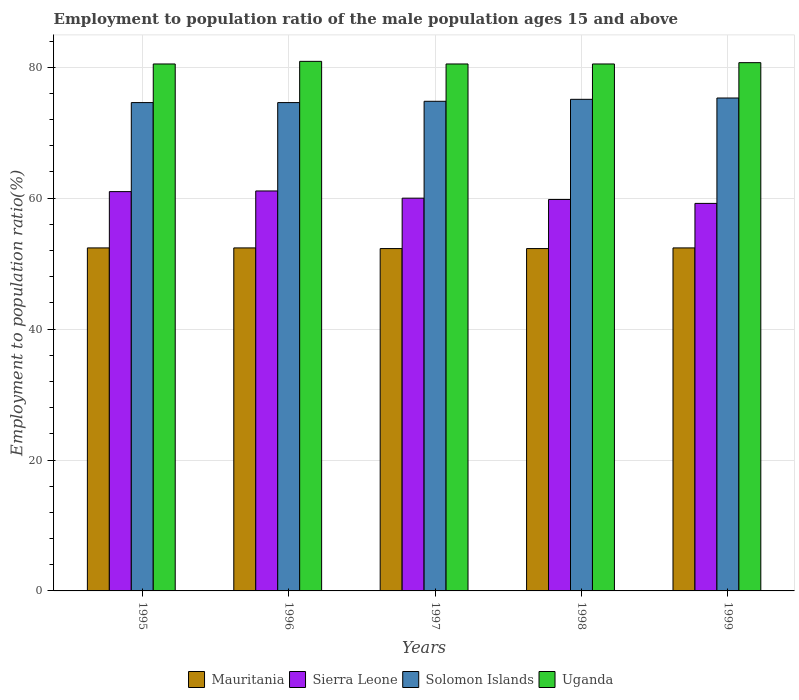How many different coloured bars are there?
Make the answer very short. 4. Are the number of bars per tick equal to the number of legend labels?
Ensure brevity in your answer.  Yes. Are the number of bars on each tick of the X-axis equal?
Offer a very short reply. Yes. How many bars are there on the 2nd tick from the left?
Offer a very short reply. 4. How many bars are there on the 2nd tick from the right?
Your response must be concise. 4. What is the employment to population ratio in Uganda in 1995?
Ensure brevity in your answer.  80.5. Across all years, what is the maximum employment to population ratio in Sierra Leone?
Give a very brief answer. 61.1. Across all years, what is the minimum employment to population ratio in Mauritania?
Your answer should be compact. 52.3. What is the total employment to population ratio in Sierra Leone in the graph?
Offer a very short reply. 301.1. What is the difference between the employment to population ratio in Uganda in 1996 and that in 1997?
Ensure brevity in your answer.  0.4. What is the difference between the employment to population ratio in Mauritania in 1997 and the employment to population ratio in Sierra Leone in 1996?
Offer a very short reply. -8.8. What is the average employment to population ratio in Uganda per year?
Offer a terse response. 80.62. In the year 1995, what is the difference between the employment to population ratio in Sierra Leone and employment to population ratio in Uganda?
Offer a very short reply. -19.5. What is the ratio of the employment to population ratio in Uganda in 1996 to that in 1997?
Make the answer very short. 1. Is the employment to population ratio in Sierra Leone in 1995 less than that in 1997?
Ensure brevity in your answer.  No. Is the difference between the employment to population ratio in Sierra Leone in 1996 and 1998 greater than the difference between the employment to population ratio in Uganda in 1996 and 1998?
Offer a terse response. Yes. What is the difference between the highest and the second highest employment to population ratio in Uganda?
Give a very brief answer. 0.2. What is the difference between the highest and the lowest employment to population ratio in Sierra Leone?
Provide a succinct answer. 1.9. Is it the case that in every year, the sum of the employment to population ratio in Uganda and employment to population ratio in Sierra Leone is greater than the sum of employment to population ratio in Mauritania and employment to population ratio in Solomon Islands?
Provide a short and direct response. No. What does the 4th bar from the left in 1998 represents?
Your answer should be compact. Uganda. What does the 1st bar from the right in 1999 represents?
Provide a short and direct response. Uganda. Is it the case that in every year, the sum of the employment to population ratio in Mauritania and employment to population ratio in Sierra Leone is greater than the employment to population ratio in Uganda?
Offer a terse response. Yes. How many bars are there?
Offer a very short reply. 20. Are all the bars in the graph horizontal?
Your response must be concise. No. What is the difference between two consecutive major ticks on the Y-axis?
Make the answer very short. 20. Are the values on the major ticks of Y-axis written in scientific E-notation?
Your answer should be very brief. No. Does the graph contain any zero values?
Your answer should be very brief. No. Where does the legend appear in the graph?
Offer a very short reply. Bottom center. What is the title of the graph?
Keep it short and to the point. Employment to population ratio of the male population ages 15 and above. What is the Employment to population ratio(%) in Mauritania in 1995?
Provide a succinct answer. 52.4. What is the Employment to population ratio(%) of Solomon Islands in 1995?
Your answer should be very brief. 74.6. What is the Employment to population ratio(%) in Uganda in 1995?
Ensure brevity in your answer.  80.5. What is the Employment to population ratio(%) in Mauritania in 1996?
Provide a succinct answer. 52.4. What is the Employment to population ratio(%) of Sierra Leone in 1996?
Provide a short and direct response. 61.1. What is the Employment to population ratio(%) of Solomon Islands in 1996?
Offer a very short reply. 74.6. What is the Employment to population ratio(%) in Uganda in 1996?
Keep it short and to the point. 80.9. What is the Employment to population ratio(%) of Mauritania in 1997?
Offer a very short reply. 52.3. What is the Employment to population ratio(%) of Solomon Islands in 1997?
Provide a short and direct response. 74.8. What is the Employment to population ratio(%) of Uganda in 1997?
Give a very brief answer. 80.5. What is the Employment to population ratio(%) of Mauritania in 1998?
Offer a very short reply. 52.3. What is the Employment to population ratio(%) in Sierra Leone in 1998?
Your response must be concise. 59.8. What is the Employment to population ratio(%) in Solomon Islands in 1998?
Your answer should be compact. 75.1. What is the Employment to population ratio(%) of Uganda in 1998?
Offer a terse response. 80.5. What is the Employment to population ratio(%) of Mauritania in 1999?
Give a very brief answer. 52.4. What is the Employment to population ratio(%) of Sierra Leone in 1999?
Your answer should be compact. 59.2. What is the Employment to population ratio(%) of Solomon Islands in 1999?
Make the answer very short. 75.3. What is the Employment to population ratio(%) in Uganda in 1999?
Give a very brief answer. 80.7. Across all years, what is the maximum Employment to population ratio(%) in Mauritania?
Provide a succinct answer. 52.4. Across all years, what is the maximum Employment to population ratio(%) in Sierra Leone?
Your response must be concise. 61.1. Across all years, what is the maximum Employment to population ratio(%) of Solomon Islands?
Provide a short and direct response. 75.3. Across all years, what is the maximum Employment to population ratio(%) in Uganda?
Provide a succinct answer. 80.9. Across all years, what is the minimum Employment to population ratio(%) in Mauritania?
Your answer should be compact. 52.3. Across all years, what is the minimum Employment to population ratio(%) of Sierra Leone?
Your answer should be compact. 59.2. Across all years, what is the minimum Employment to population ratio(%) in Solomon Islands?
Make the answer very short. 74.6. Across all years, what is the minimum Employment to population ratio(%) in Uganda?
Offer a terse response. 80.5. What is the total Employment to population ratio(%) of Mauritania in the graph?
Ensure brevity in your answer.  261.8. What is the total Employment to population ratio(%) of Sierra Leone in the graph?
Offer a terse response. 301.1. What is the total Employment to population ratio(%) in Solomon Islands in the graph?
Ensure brevity in your answer.  374.4. What is the total Employment to population ratio(%) in Uganda in the graph?
Your answer should be compact. 403.1. What is the difference between the Employment to population ratio(%) of Mauritania in 1995 and that in 1996?
Provide a short and direct response. 0. What is the difference between the Employment to population ratio(%) in Uganda in 1995 and that in 1996?
Offer a very short reply. -0.4. What is the difference between the Employment to population ratio(%) of Mauritania in 1995 and that in 1997?
Provide a succinct answer. 0.1. What is the difference between the Employment to population ratio(%) of Solomon Islands in 1995 and that in 1997?
Offer a very short reply. -0.2. What is the difference between the Employment to population ratio(%) in Solomon Islands in 1995 and that in 1998?
Provide a succinct answer. -0.5. What is the difference between the Employment to population ratio(%) of Uganda in 1995 and that in 1998?
Give a very brief answer. 0. What is the difference between the Employment to population ratio(%) in Sierra Leone in 1995 and that in 1999?
Provide a short and direct response. 1.8. What is the difference between the Employment to population ratio(%) of Solomon Islands in 1995 and that in 1999?
Give a very brief answer. -0.7. What is the difference between the Employment to population ratio(%) in Uganda in 1995 and that in 1999?
Make the answer very short. -0.2. What is the difference between the Employment to population ratio(%) in Uganda in 1996 and that in 1997?
Your response must be concise. 0.4. What is the difference between the Employment to population ratio(%) of Sierra Leone in 1996 and that in 1998?
Provide a short and direct response. 1.3. What is the difference between the Employment to population ratio(%) in Mauritania in 1997 and that in 1998?
Your response must be concise. 0. What is the difference between the Employment to population ratio(%) of Solomon Islands in 1997 and that in 1999?
Give a very brief answer. -0.5. What is the difference between the Employment to population ratio(%) in Mauritania in 1998 and that in 1999?
Your response must be concise. -0.1. What is the difference between the Employment to population ratio(%) in Solomon Islands in 1998 and that in 1999?
Give a very brief answer. -0.2. What is the difference between the Employment to population ratio(%) in Mauritania in 1995 and the Employment to population ratio(%) in Solomon Islands in 1996?
Offer a very short reply. -22.2. What is the difference between the Employment to population ratio(%) in Mauritania in 1995 and the Employment to population ratio(%) in Uganda in 1996?
Your answer should be compact. -28.5. What is the difference between the Employment to population ratio(%) in Sierra Leone in 1995 and the Employment to population ratio(%) in Solomon Islands in 1996?
Give a very brief answer. -13.6. What is the difference between the Employment to population ratio(%) of Sierra Leone in 1995 and the Employment to population ratio(%) of Uganda in 1996?
Provide a short and direct response. -19.9. What is the difference between the Employment to population ratio(%) of Solomon Islands in 1995 and the Employment to population ratio(%) of Uganda in 1996?
Offer a very short reply. -6.3. What is the difference between the Employment to population ratio(%) of Mauritania in 1995 and the Employment to population ratio(%) of Sierra Leone in 1997?
Ensure brevity in your answer.  -7.6. What is the difference between the Employment to population ratio(%) in Mauritania in 1995 and the Employment to population ratio(%) in Solomon Islands in 1997?
Make the answer very short. -22.4. What is the difference between the Employment to population ratio(%) of Mauritania in 1995 and the Employment to population ratio(%) of Uganda in 1997?
Provide a succinct answer. -28.1. What is the difference between the Employment to population ratio(%) in Sierra Leone in 1995 and the Employment to population ratio(%) in Solomon Islands in 1997?
Offer a terse response. -13.8. What is the difference between the Employment to population ratio(%) in Sierra Leone in 1995 and the Employment to population ratio(%) in Uganda in 1997?
Your answer should be very brief. -19.5. What is the difference between the Employment to population ratio(%) in Solomon Islands in 1995 and the Employment to population ratio(%) in Uganda in 1997?
Offer a very short reply. -5.9. What is the difference between the Employment to population ratio(%) in Mauritania in 1995 and the Employment to population ratio(%) in Sierra Leone in 1998?
Offer a very short reply. -7.4. What is the difference between the Employment to population ratio(%) of Mauritania in 1995 and the Employment to population ratio(%) of Solomon Islands in 1998?
Your answer should be compact. -22.7. What is the difference between the Employment to population ratio(%) in Mauritania in 1995 and the Employment to population ratio(%) in Uganda in 1998?
Offer a terse response. -28.1. What is the difference between the Employment to population ratio(%) of Sierra Leone in 1995 and the Employment to population ratio(%) of Solomon Islands in 1998?
Keep it short and to the point. -14.1. What is the difference between the Employment to population ratio(%) in Sierra Leone in 1995 and the Employment to population ratio(%) in Uganda in 1998?
Provide a short and direct response. -19.5. What is the difference between the Employment to population ratio(%) in Solomon Islands in 1995 and the Employment to population ratio(%) in Uganda in 1998?
Provide a short and direct response. -5.9. What is the difference between the Employment to population ratio(%) of Mauritania in 1995 and the Employment to population ratio(%) of Sierra Leone in 1999?
Offer a terse response. -6.8. What is the difference between the Employment to population ratio(%) in Mauritania in 1995 and the Employment to population ratio(%) in Solomon Islands in 1999?
Offer a very short reply. -22.9. What is the difference between the Employment to population ratio(%) in Mauritania in 1995 and the Employment to population ratio(%) in Uganda in 1999?
Offer a very short reply. -28.3. What is the difference between the Employment to population ratio(%) of Sierra Leone in 1995 and the Employment to population ratio(%) of Solomon Islands in 1999?
Keep it short and to the point. -14.3. What is the difference between the Employment to population ratio(%) in Sierra Leone in 1995 and the Employment to population ratio(%) in Uganda in 1999?
Provide a succinct answer. -19.7. What is the difference between the Employment to population ratio(%) of Mauritania in 1996 and the Employment to population ratio(%) of Solomon Islands in 1997?
Provide a short and direct response. -22.4. What is the difference between the Employment to population ratio(%) of Mauritania in 1996 and the Employment to population ratio(%) of Uganda in 1997?
Provide a succinct answer. -28.1. What is the difference between the Employment to population ratio(%) in Sierra Leone in 1996 and the Employment to population ratio(%) in Solomon Islands in 1997?
Give a very brief answer. -13.7. What is the difference between the Employment to population ratio(%) of Sierra Leone in 1996 and the Employment to population ratio(%) of Uganda in 1997?
Ensure brevity in your answer.  -19.4. What is the difference between the Employment to population ratio(%) of Mauritania in 1996 and the Employment to population ratio(%) of Solomon Islands in 1998?
Make the answer very short. -22.7. What is the difference between the Employment to population ratio(%) in Mauritania in 1996 and the Employment to population ratio(%) in Uganda in 1998?
Provide a short and direct response. -28.1. What is the difference between the Employment to population ratio(%) in Sierra Leone in 1996 and the Employment to population ratio(%) in Uganda in 1998?
Your answer should be compact. -19.4. What is the difference between the Employment to population ratio(%) in Solomon Islands in 1996 and the Employment to population ratio(%) in Uganda in 1998?
Give a very brief answer. -5.9. What is the difference between the Employment to population ratio(%) in Mauritania in 1996 and the Employment to population ratio(%) in Solomon Islands in 1999?
Your answer should be compact. -22.9. What is the difference between the Employment to population ratio(%) in Mauritania in 1996 and the Employment to population ratio(%) in Uganda in 1999?
Your response must be concise. -28.3. What is the difference between the Employment to population ratio(%) in Sierra Leone in 1996 and the Employment to population ratio(%) in Solomon Islands in 1999?
Provide a succinct answer. -14.2. What is the difference between the Employment to population ratio(%) of Sierra Leone in 1996 and the Employment to population ratio(%) of Uganda in 1999?
Give a very brief answer. -19.6. What is the difference between the Employment to population ratio(%) in Solomon Islands in 1996 and the Employment to population ratio(%) in Uganda in 1999?
Offer a very short reply. -6.1. What is the difference between the Employment to population ratio(%) of Mauritania in 1997 and the Employment to population ratio(%) of Sierra Leone in 1998?
Your answer should be very brief. -7.5. What is the difference between the Employment to population ratio(%) of Mauritania in 1997 and the Employment to population ratio(%) of Solomon Islands in 1998?
Make the answer very short. -22.8. What is the difference between the Employment to population ratio(%) of Mauritania in 1997 and the Employment to population ratio(%) of Uganda in 1998?
Keep it short and to the point. -28.2. What is the difference between the Employment to population ratio(%) in Sierra Leone in 1997 and the Employment to population ratio(%) in Solomon Islands in 1998?
Ensure brevity in your answer.  -15.1. What is the difference between the Employment to population ratio(%) of Sierra Leone in 1997 and the Employment to population ratio(%) of Uganda in 1998?
Offer a very short reply. -20.5. What is the difference between the Employment to population ratio(%) of Solomon Islands in 1997 and the Employment to population ratio(%) of Uganda in 1998?
Your response must be concise. -5.7. What is the difference between the Employment to population ratio(%) of Mauritania in 1997 and the Employment to population ratio(%) of Sierra Leone in 1999?
Make the answer very short. -6.9. What is the difference between the Employment to population ratio(%) in Mauritania in 1997 and the Employment to population ratio(%) in Solomon Islands in 1999?
Ensure brevity in your answer.  -23. What is the difference between the Employment to population ratio(%) of Mauritania in 1997 and the Employment to population ratio(%) of Uganda in 1999?
Ensure brevity in your answer.  -28.4. What is the difference between the Employment to population ratio(%) of Sierra Leone in 1997 and the Employment to population ratio(%) of Solomon Islands in 1999?
Keep it short and to the point. -15.3. What is the difference between the Employment to population ratio(%) in Sierra Leone in 1997 and the Employment to population ratio(%) in Uganda in 1999?
Offer a terse response. -20.7. What is the difference between the Employment to population ratio(%) in Mauritania in 1998 and the Employment to population ratio(%) in Solomon Islands in 1999?
Give a very brief answer. -23. What is the difference between the Employment to population ratio(%) in Mauritania in 1998 and the Employment to population ratio(%) in Uganda in 1999?
Your response must be concise. -28.4. What is the difference between the Employment to population ratio(%) in Sierra Leone in 1998 and the Employment to population ratio(%) in Solomon Islands in 1999?
Your answer should be very brief. -15.5. What is the difference between the Employment to population ratio(%) in Sierra Leone in 1998 and the Employment to population ratio(%) in Uganda in 1999?
Make the answer very short. -20.9. What is the average Employment to population ratio(%) in Mauritania per year?
Your answer should be very brief. 52.36. What is the average Employment to population ratio(%) of Sierra Leone per year?
Provide a short and direct response. 60.22. What is the average Employment to population ratio(%) of Solomon Islands per year?
Offer a very short reply. 74.88. What is the average Employment to population ratio(%) of Uganda per year?
Your answer should be compact. 80.62. In the year 1995, what is the difference between the Employment to population ratio(%) in Mauritania and Employment to population ratio(%) in Sierra Leone?
Your answer should be very brief. -8.6. In the year 1995, what is the difference between the Employment to population ratio(%) of Mauritania and Employment to population ratio(%) of Solomon Islands?
Keep it short and to the point. -22.2. In the year 1995, what is the difference between the Employment to population ratio(%) in Mauritania and Employment to population ratio(%) in Uganda?
Your response must be concise. -28.1. In the year 1995, what is the difference between the Employment to population ratio(%) in Sierra Leone and Employment to population ratio(%) in Solomon Islands?
Give a very brief answer. -13.6. In the year 1995, what is the difference between the Employment to population ratio(%) in Sierra Leone and Employment to population ratio(%) in Uganda?
Provide a succinct answer. -19.5. In the year 1995, what is the difference between the Employment to population ratio(%) of Solomon Islands and Employment to population ratio(%) of Uganda?
Keep it short and to the point. -5.9. In the year 1996, what is the difference between the Employment to population ratio(%) in Mauritania and Employment to population ratio(%) in Sierra Leone?
Make the answer very short. -8.7. In the year 1996, what is the difference between the Employment to population ratio(%) of Mauritania and Employment to population ratio(%) of Solomon Islands?
Offer a very short reply. -22.2. In the year 1996, what is the difference between the Employment to population ratio(%) in Mauritania and Employment to population ratio(%) in Uganda?
Give a very brief answer. -28.5. In the year 1996, what is the difference between the Employment to population ratio(%) of Sierra Leone and Employment to population ratio(%) of Uganda?
Provide a short and direct response. -19.8. In the year 1997, what is the difference between the Employment to population ratio(%) of Mauritania and Employment to population ratio(%) of Solomon Islands?
Make the answer very short. -22.5. In the year 1997, what is the difference between the Employment to population ratio(%) in Mauritania and Employment to population ratio(%) in Uganda?
Provide a succinct answer. -28.2. In the year 1997, what is the difference between the Employment to population ratio(%) in Sierra Leone and Employment to population ratio(%) in Solomon Islands?
Give a very brief answer. -14.8. In the year 1997, what is the difference between the Employment to population ratio(%) in Sierra Leone and Employment to population ratio(%) in Uganda?
Keep it short and to the point. -20.5. In the year 1998, what is the difference between the Employment to population ratio(%) of Mauritania and Employment to population ratio(%) of Sierra Leone?
Provide a succinct answer. -7.5. In the year 1998, what is the difference between the Employment to population ratio(%) of Mauritania and Employment to population ratio(%) of Solomon Islands?
Your response must be concise. -22.8. In the year 1998, what is the difference between the Employment to population ratio(%) in Mauritania and Employment to population ratio(%) in Uganda?
Offer a terse response. -28.2. In the year 1998, what is the difference between the Employment to population ratio(%) of Sierra Leone and Employment to population ratio(%) of Solomon Islands?
Offer a very short reply. -15.3. In the year 1998, what is the difference between the Employment to population ratio(%) in Sierra Leone and Employment to population ratio(%) in Uganda?
Make the answer very short. -20.7. In the year 1999, what is the difference between the Employment to population ratio(%) in Mauritania and Employment to population ratio(%) in Solomon Islands?
Provide a succinct answer. -22.9. In the year 1999, what is the difference between the Employment to population ratio(%) of Mauritania and Employment to population ratio(%) of Uganda?
Offer a terse response. -28.3. In the year 1999, what is the difference between the Employment to population ratio(%) of Sierra Leone and Employment to population ratio(%) of Solomon Islands?
Ensure brevity in your answer.  -16.1. In the year 1999, what is the difference between the Employment to population ratio(%) in Sierra Leone and Employment to population ratio(%) in Uganda?
Keep it short and to the point. -21.5. What is the ratio of the Employment to population ratio(%) of Solomon Islands in 1995 to that in 1996?
Ensure brevity in your answer.  1. What is the ratio of the Employment to population ratio(%) of Mauritania in 1995 to that in 1997?
Provide a succinct answer. 1. What is the ratio of the Employment to population ratio(%) of Sierra Leone in 1995 to that in 1997?
Make the answer very short. 1.02. What is the ratio of the Employment to population ratio(%) of Mauritania in 1995 to that in 1998?
Make the answer very short. 1. What is the ratio of the Employment to population ratio(%) of Sierra Leone in 1995 to that in 1998?
Provide a succinct answer. 1.02. What is the ratio of the Employment to population ratio(%) in Solomon Islands in 1995 to that in 1998?
Your answer should be compact. 0.99. What is the ratio of the Employment to population ratio(%) in Uganda in 1995 to that in 1998?
Give a very brief answer. 1. What is the ratio of the Employment to population ratio(%) in Sierra Leone in 1995 to that in 1999?
Make the answer very short. 1.03. What is the ratio of the Employment to population ratio(%) of Uganda in 1995 to that in 1999?
Give a very brief answer. 1. What is the ratio of the Employment to population ratio(%) in Sierra Leone in 1996 to that in 1997?
Keep it short and to the point. 1.02. What is the ratio of the Employment to population ratio(%) in Solomon Islands in 1996 to that in 1997?
Keep it short and to the point. 1. What is the ratio of the Employment to population ratio(%) in Uganda in 1996 to that in 1997?
Give a very brief answer. 1. What is the ratio of the Employment to population ratio(%) in Mauritania in 1996 to that in 1998?
Provide a succinct answer. 1. What is the ratio of the Employment to population ratio(%) in Sierra Leone in 1996 to that in 1998?
Offer a very short reply. 1.02. What is the ratio of the Employment to population ratio(%) in Solomon Islands in 1996 to that in 1998?
Your answer should be compact. 0.99. What is the ratio of the Employment to population ratio(%) of Uganda in 1996 to that in 1998?
Your answer should be very brief. 1. What is the ratio of the Employment to population ratio(%) in Mauritania in 1996 to that in 1999?
Keep it short and to the point. 1. What is the ratio of the Employment to population ratio(%) of Sierra Leone in 1996 to that in 1999?
Keep it short and to the point. 1.03. What is the ratio of the Employment to population ratio(%) in Mauritania in 1997 to that in 1998?
Your response must be concise. 1. What is the ratio of the Employment to population ratio(%) of Sierra Leone in 1997 to that in 1998?
Provide a succinct answer. 1. What is the ratio of the Employment to population ratio(%) of Solomon Islands in 1997 to that in 1998?
Ensure brevity in your answer.  1. What is the ratio of the Employment to population ratio(%) of Sierra Leone in 1997 to that in 1999?
Your answer should be compact. 1.01. What is the ratio of the Employment to population ratio(%) in Solomon Islands in 1997 to that in 1999?
Provide a short and direct response. 0.99. What is the ratio of the Employment to population ratio(%) in Solomon Islands in 1998 to that in 1999?
Provide a succinct answer. 1. What is the difference between the highest and the second highest Employment to population ratio(%) in Mauritania?
Provide a succinct answer. 0. What is the difference between the highest and the second highest Employment to population ratio(%) of Sierra Leone?
Ensure brevity in your answer.  0.1. What is the difference between the highest and the second highest Employment to population ratio(%) in Uganda?
Provide a short and direct response. 0.2. What is the difference between the highest and the lowest Employment to population ratio(%) in Sierra Leone?
Provide a short and direct response. 1.9. What is the difference between the highest and the lowest Employment to population ratio(%) of Uganda?
Your answer should be very brief. 0.4. 